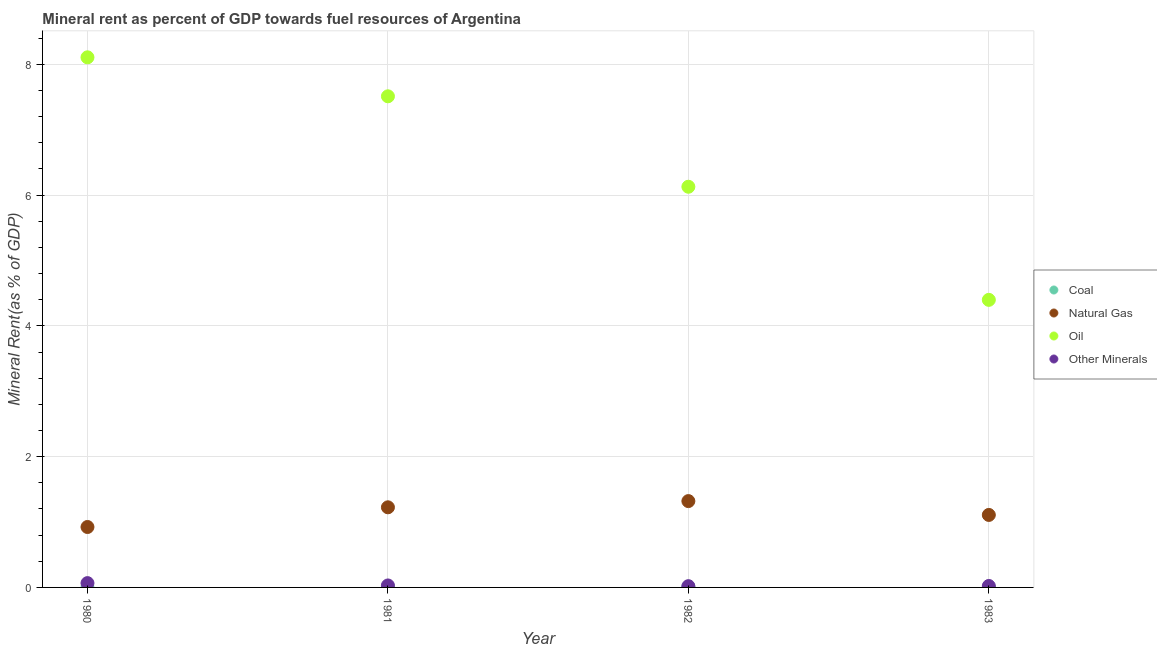How many different coloured dotlines are there?
Make the answer very short. 4. What is the coal rent in 1983?
Offer a very short reply. 0. Across all years, what is the maximum natural gas rent?
Provide a short and direct response. 1.32. Across all years, what is the minimum  rent of other minerals?
Provide a succinct answer. 0.02. What is the total oil rent in the graph?
Make the answer very short. 26.14. What is the difference between the coal rent in 1980 and that in 1983?
Your response must be concise. 0. What is the difference between the natural gas rent in 1982 and the coal rent in 1983?
Offer a terse response. 1.32. What is the average natural gas rent per year?
Provide a succinct answer. 1.14. In the year 1981, what is the difference between the oil rent and  rent of other minerals?
Offer a very short reply. 7.48. What is the ratio of the  rent of other minerals in 1980 to that in 1983?
Your response must be concise. 2.97. Is the difference between the coal rent in 1980 and 1981 greater than the difference between the natural gas rent in 1980 and 1981?
Keep it short and to the point. Yes. What is the difference between the highest and the second highest natural gas rent?
Offer a terse response. 0.1. What is the difference between the highest and the lowest natural gas rent?
Your answer should be very brief. 0.4. Is the sum of the natural gas rent in 1981 and 1982 greater than the maximum coal rent across all years?
Offer a terse response. Yes. Is the natural gas rent strictly less than the  rent of other minerals over the years?
Make the answer very short. No. How many dotlines are there?
Your answer should be very brief. 4. How many years are there in the graph?
Keep it short and to the point. 4. What is the difference between two consecutive major ticks on the Y-axis?
Make the answer very short. 2. Are the values on the major ticks of Y-axis written in scientific E-notation?
Give a very brief answer. No. Does the graph contain any zero values?
Your answer should be compact. No. Does the graph contain grids?
Offer a terse response. Yes. What is the title of the graph?
Make the answer very short. Mineral rent as percent of GDP towards fuel resources of Argentina. What is the label or title of the X-axis?
Offer a terse response. Year. What is the label or title of the Y-axis?
Ensure brevity in your answer.  Mineral Rent(as % of GDP). What is the Mineral Rent(as % of GDP) in Coal in 1980?
Your response must be concise. 0. What is the Mineral Rent(as % of GDP) in Natural Gas in 1980?
Provide a short and direct response. 0.92. What is the Mineral Rent(as % of GDP) in Oil in 1980?
Offer a terse response. 8.11. What is the Mineral Rent(as % of GDP) of Other Minerals in 1980?
Offer a terse response. 0.07. What is the Mineral Rent(as % of GDP) in Coal in 1981?
Offer a terse response. 0.01. What is the Mineral Rent(as % of GDP) in Natural Gas in 1981?
Offer a terse response. 1.23. What is the Mineral Rent(as % of GDP) in Oil in 1981?
Give a very brief answer. 7.51. What is the Mineral Rent(as % of GDP) in Other Minerals in 1981?
Keep it short and to the point. 0.03. What is the Mineral Rent(as % of GDP) in Coal in 1982?
Your answer should be compact. 0.01. What is the Mineral Rent(as % of GDP) of Natural Gas in 1982?
Ensure brevity in your answer.  1.32. What is the Mineral Rent(as % of GDP) in Oil in 1982?
Offer a terse response. 6.13. What is the Mineral Rent(as % of GDP) of Other Minerals in 1982?
Provide a short and direct response. 0.02. What is the Mineral Rent(as % of GDP) of Coal in 1983?
Offer a terse response. 0. What is the Mineral Rent(as % of GDP) in Natural Gas in 1983?
Make the answer very short. 1.11. What is the Mineral Rent(as % of GDP) in Oil in 1983?
Keep it short and to the point. 4.4. What is the Mineral Rent(as % of GDP) in Other Minerals in 1983?
Offer a terse response. 0.02. Across all years, what is the maximum Mineral Rent(as % of GDP) of Coal?
Your response must be concise. 0.01. Across all years, what is the maximum Mineral Rent(as % of GDP) of Natural Gas?
Provide a short and direct response. 1.32. Across all years, what is the maximum Mineral Rent(as % of GDP) in Oil?
Provide a succinct answer. 8.11. Across all years, what is the maximum Mineral Rent(as % of GDP) in Other Minerals?
Your answer should be very brief. 0.07. Across all years, what is the minimum Mineral Rent(as % of GDP) of Coal?
Your response must be concise. 0. Across all years, what is the minimum Mineral Rent(as % of GDP) in Natural Gas?
Give a very brief answer. 0.92. Across all years, what is the minimum Mineral Rent(as % of GDP) of Oil?
Your answer should be very brief. 4.4. Across all years, what is the minimum Mineral Rent(as % of GDP) of Other Minerals?
Offer a terse response. 0.02. What is the total Mineral Rent(as % of GDP) of Coal in the graph?
Offer a very short reply. 0.02. What is the total Mineral Rent(as % of GDP) of Natural Gas in the graph?
Provide a short and direct response. 4.58. What is the total Mineral Rent(as % of GDP) in Oil in the graph?
Provide a succinct answer. 26.14. What is the total Mineral Rent(as % of GDP) in Other Minerals in the graph?
Make the answer very short. 0.14. What is the difference between the Mineral Rent(as % of GDP) of Coal in 1980 and that in 1981?
Make the answer very short. -0.01. What is the difference between the Mineral Rent(as % of GDP) of Natural Gas in 1980 and that in 1981?
Give a very brief answer. -0.3. What is the difference between the Mineral Rent(as % of GDP) of Oil in 1980 and that in 1981?
Your answer should be compact. 0.6. What is the difference between the Mineral Rent(as % of GDP) in Other Minerals in 1980 and that in 1981?
Provide a short and direct response. 0.04. What is the difference between the Mineral Rent(as % of GDP) of Coal in 1980 and that in 1982?
Provide a succinct answer. -0.01. What is the difference between the Mineral Rent(as % of GDP) in Natural Gas in 1980 and that in 1982?
Ensure brevity in your answer.  -0.4. What is the difference between the Mineral Rent(as % of GDP) of Oil in 1980 and that in 1982?
Ensure brevity in your answer.  1.98. What is the difference between the Mineral Rent(as % of GDP) of Other Minerals in 1980 and that in 1982?
Keep it short and to the point. 0.05. What is the difference between the Mineral Rent(as % of GDP) in Natural Gas in 1980 and that in 1983?
Your answer should be very brief. -0.18. What is the difference between the Mineral Rent(as % of GDP) in Oil in 1980 and that in 1983?
Give a very brief answer. 3.71. What is the difference between the Mineral Rent(as % of GDP) in Other Minerals in 1980 and that in 1983?
Keep it short and to the point. 0.04. What is the difference between the Mineral Rent(as % of GDP) in Coal in 1981 and that in 1982?
Ensure brevity in your answer.  -0. What is the difference between the Mineral Rent(as % of GDP) of Natural Gas in 1981 and that in 1982?
Give a very brief answer. -0.1. What is the difference between the Mineral Rent(as % of GDP) of Oil in 1981 and that in 1982?
Your answer should be very brief. 1.38. What is the difference between the Mineral Rent(as % of GDP) of Other Minerals in 1981 and that in 1982?
Keep it short and to the point. 0.01. What is the difference between the Mineral Rent(as % of GDP) of Coal in 1981 and that in 1983?
Give a very brief answer. 0.01. What is the difference between the Mineral Rent(as % of GDP) in Natural Gas in 1981 and that in 1983?
Make the answer very short. 0.12. What is the difference between the Mineral Rent(as % of GDP) in Oil in 1981 and that in 1983?
Provide a succinct answer. 3.11. What is the difference between the Mineral Rent(as % of GDP) in Other Minerals in 1981 and that in 1983?
Offer a very short reply. 0.01. What is the difference between the Mineral Rent(as % of GDP) in Coal in 1982 and that in 1983?
Make the answer very short. 0.01. What is the difference between the Mineral Rent(as % of GDP) of Natural Gas in 1982 and that in 1983?
Give a very brief answer. 0.21. What is the difference between the Mineral Rent(as % of GDP) of Oil in 1982 and that in 1983?
Provide a short and direct response. 1.73. What is the difference between the Mineral Rent(as % of GDP) in Other Minerals in 1982 and that in 1983?
Give a very brief answer. -0. What is the difference between the Mineral Rent(as % of GDP) of Coal in 1980 and the Mineral Rent(as % of GDP) of Natural Gas in 1981?
Make the answer very short. -1.22. What is the difference between the Mineral Rent(as % of GDP) of Coal in 1980 and the Mineral Rent(as % of GDP) of Oil in 1981?
Provide a succinct answer. -7.51. What is the difference between the Mineral Rent(as % of GDP) of Coal in 1980 and the Mineral Rent(as % of GDP) of Other Minerals in 1981?
Provide a short and direct response. -0.03. What is the difference between the Mineral Rent(as % of GDP) of Natural Gas in 1980 and the Mineral Rent(as % of GDP) of Oil in 1981?
Keep it short and to the point. -6.59. What is the difference between the Mineral Rent(as % of GDP) in Natural Gas in 1980 and the Mineral Rent(as % of GDP) in Other Minerals in 1981?
Offer a terse response. 0.89. What is the difference between the Mineral Rent(as % of GDP) in Oil in 1980 and the Mineral Rent(as % of GDP) in Other Minerals in 1981?
Make the answer very short. 8.08. What is the difference between the Mineral Rent(as % of GDP) of Coal in 1980 and the Mineral Rent(as % of GDP) of Natural Gas in 1982?
Give a very brief answer. -1.32. What is the difference between the Mineral Rent(as % of GDP) in Coal in 1980 and the Mineral Rent(as % of GDP) in Oil in 1982?
Offer a terse response. -6.13. What is the difference between the Mineral Rent(as % of GDP) of Coal in 1980 and the Mineral Rent(as % of GDP) of Other Minerals in 1982?
Your response must be concise. -0.02. What is the difference between the Mineral Rent(as % of GDP) of Natural Gas in 1980 and the Mineral Rent(as % of GDP) of Oil in 1982?
Ensure brevity in your answer.  -5.2. What is the difference between the Mineral Rent(as % of GDP) of Natural Gas in 1980 and the Mineral Rent(as % of GDP) of Other Minerals in 1982?
Provide a short and direct response. 0.91. What is the difference between the Mineral Rent(as % of GDP) of Oil in 1980 and the Mineral Rent(as % of GDP) of Other Minerals in 1982?
Make the answer very short. 8.09. What is the difference between the Mineral Rent(as % of GDP) in Coal in 1980 and the Mineral Rent(as % of GDP) in Natural Gas in 1983?
Offer a terse response. -1.11. What is the difference between the Mineral Rent(as % of GDP) of Coal in 1980 and the Mineral Rent(as % of GDP) of Oil in 1983?
Provide a short and direct response. -4.4. What is the difference between the Mineral Rent(as % of GDP) in Coal in 1980 and the Mineral Rent(as % of GDP) in Other Minerals in 1983?
Provide a succinct answer. -0.02. What is the difference between the Mineral Rent(as % of GDP) of Natural Gas in 1980 and the Mineral Rent(as % of GDP) of Oil in 1983?
Offer a very short reply. -3.47. What is the difference between the Mineral Rent(as % of GDP) in Natural Gas in 1980 and the Mineral Rent(as % of GDP) in Other Minerals in 1983?
Your answer should be very brief. 0.9. What is the difference between the Mineral Rent(as % of GDP) in Oil in 1980 and the Mineral Rent(as % of GDP) in Other Minerals in 1983?
Provide a short and direct response. 8.08. What is the difference between the Mineral Rent(as % of GDP) in Coal in 1981 and the Mineral Rent(as % of GDP) in Natural Gas in 1982?
Provide a short and direct response. -1.31. What is the difference between the Mineral Rent(as % of GDP) of Coal in 1981 and the Mineral Rent(as % of GDP) of Oil in 1982?
Offer a very short reply. -6.12. What is the difference between the Mineral Rent(as % of GDP) of Coal in 1981 and the Mineral Rent(as % of GDP) of Other Minerals in 1982?
Keep it short and to the point. -0.01. What is the difference between the Mineral Rent(as % of GDP) in Natural Gas in 1981 and the Mineral Rent(as % of GDP) in Oil in 1982?
Provide a succinct answer. -4.9. What is the difference between the Mineral Rent(as % of GDP) of Natural Gas in 1981 and the Mineral Rent(as % of GDP) of Other Minerals in 1982?
Keep it short and to the point. 1.21. What is the difference between the Mineral Rent(as % of GDP) in Oil in 1981 and the Mineral Rent(as % of GDP) in Other Minerals in 1982?
Offer a terse response. 7.49. What is the difference between the Mineral Rent(as % of GDP) of Coal in 1981 and the Mineral Rent(as % of GDP) of Natural Gas in 1983?
Offer a terse response. -1.1. What is the difference between the Mineral Rent(as % of GDP) in Coal in 1981 and the Mineral Rent(as % of GDP) in Oil in 1983?
Offer a terse response. -4.39. What is the difference between the Mineral Rent(as % of GDP) in Coal in 1981 and the Mineral Rent(as % of GDP) in Other Minerals in 1983?
Offer a terse response. -0.01. What is the difference between the Mineral Rent(as % of GDP) in Natural Gas in 1981 and the Mineral Rent(as % of GDP) in Oil in 1983?
Make the answer very short. -3.17. What is the difference between the Mineral Rent(as % of GDP) of Natural Gas in 1981 and the Mineral Rent(as % of GDP) of Other Minerals in 1983?
Make the answer very short. 1.2. What is the difference between the Mineral Rent(as % of GDP) in Oil in 1981 and the Mineral Rent(as % of GDP) in Other Minerals in 1983?
Keep it short and to the point. 7.49. What is the difference between the Mineral Rent(as % of GDP) in Coal in 1982 and the Mineral Rent(as % of GDP) in Natural Gas in 1983?
Give a very brief answer. -1.1. What is the difference between the Mineral Rent(as % of GDP) in Coal in 1982 and the Mineral Rent(as % of GDP) in Oil in 1983?
Make the answer very short. -4.39. What is the difference between the Mineral Rent(as % of GDP) in Coal in 1982 and the Mineral Rent(as % of GDP) in Other Minerals in 1983?
Provide a succinct answer. -0.01. What is the difference between the Mineral Rent(as % of GDP) of Natural Gas in 1982 and the Mineral Rent(as % of GDP) of Oil in 1983?
Offer a terse response. -3.08. What is the difference between the Mineral Rent(as % of GDP) in Natural Gas in 1982 and the Mineral Rent(as % of GDP) in Other Minerals in 1983?
Give a very brief answer. 1.3. What is the difference between the Mineral Rent(as % of GDP) in Oil in 1982 and the Mineral Rent(as % of GDP) in Other Minerals in 1983?
Your answer should be very brief. 6.11. What is the average Mineral Rent(as % of GDP) in Coal per year?
Keep it short and to the point. 0.01. What is the average Mineral Rent(as % of GDP) in Natural Gas per year?
Make the answer very short. 1.14. What is the average Mineral Rent(as % of GDP) in Oil per year?
Give a very brief answer. 6.54. What is the average Mineral Rent(as % of GDP) of Other Minerals per year?
Offer a very short reply. 0.03. In the year 1980, what is the difference between the Mineral Rent(as % of GDP) of Coal and Mineral Rent(as % of GDP) of Natural Gas?
Ensure brevity in your answer.  -0.92. In the year 1980, what is the difference between the Mineral Rent(as % of GDP) in Coal and Mineral Rent(as % of GDP) in Oil?
Your answer should be very brief. -8.11. In the year 1980, what is the difference between the Mineral Rent(as % of GDP) of Coal and Mineral Rent(as % of GDP) of Other Minerals?
Your answer should be compact. -0.06. In the year 1980, what is the difference between the Mineral Rent(as % of GDP) in Natural Gas and Mineral Rent(as % of GDP) in Oil?
Your response must be concise. -7.18. In the year 1980, what is the difference between the Mineral Rent(as % of GDP) in Natural Gas and Mineral Rent(as % of GDP) in Other Minerals?
Offer a terse response. 0.86. In the year 1980, what is the difference between the Mineral Rent(as % of GDP) in Oil and Mineral Rent(as % of GDP) in Other Minerals?
Your answer should be compact. 8.04. In the year 1981, what is the difference between the Mineral Rent(as % of GDP) of Coal and Mineral Rent(as % of GDP) of Natural Gas?
Give a very brief answer. -1.22. In the year 1981, what is the difference between the Mineral Rent(as % of GDP) of Coal and Mineral Rent(as % of GDP) of Oil?
Your response must be concise. -7.5. In the year 1981, what is the difference between the Mineral Rent(as % of GDP) of Coal and Mineral Rent(as % of GDP) of Other Minerals?
Offer a terse response. -0.02. In the year 1981, what is the difference between the Mineral Rent(as % of GDP) of Natural Gas and Mineral Rent(as % of GDP) of Oil?
Offer a very short reply. -6.29. In the year 1981, what is the difference between the Mineral Rent(as % of GDP) in Natural Gas and Mineral Rent(as % of GDP) in Other Minerals?
Provide a short and direct response. 1.2. In the year 1981, what is the difference between the Mineral Rent(as % of GDP) of Oil and Mineral Rent(as % of GDP) of Other Minerals?
Make the answer very short. 7.48. In the year 1982, what is the difference between the Mineral Rent(as % of GDP) of Coal and Mineral Rent(as % of GDP) of Natural Gas?
Ensure brevity in your answer.  -1.31. In the year 1982, what is the difference between the Mineral Rent(as % of GDP) in Coal and Mineral Rent(as % of GDP) in Oil?
Offer a terse response. -6.12. In the year 1982, what is the difference between the Mineral Rent(as % of GDP) of Coal and Mineral Rent(as % of GDP) of Other Minerals?
Keep it short and to the point. -0.01. In the year 1982, what is the difference between the Mineral Rent(as % of GDP) in Natural Gas and Mineral Rent(as % of GDP) in Oil?
Offer a very short reply. -4.81. In the year 1982, what is the difference between the Mineral Rent(as % of GDP) of Natural Gas and Mineral Rent(as % of GDP) of Other Minerals?
Your answer should be very brief. 1.3. In the year 1982, what is the difference between the Mineral Rent(as % of GDP) in Oil and Mineral Rent(as % of GDP) in Other Minerals?
Keep it short and to the point. 6.11. In the year 1983, what is the difference between the Mineral Rent(as % of GDP) of Coal and Mineral Rent(as % of GDP) of Natural Gas?
Provide a short and direct response. -1.11. In the year 1983, what is the difference between the Mineral Rent(as % of GDP) of Coal and Mineral Rent(as % of GDP) of Oil?
Your response must be concise. -4.4. In the year 1983, what is the difference between the Mineral Rent(as % of GDP) of Coal and Mineral Rent(as % of GDP) of Other Minerals?
Your answer should be compact. -0.02. In the year 1983, what is the difference between the Mineral Rent(as % of GDP) of Natural Gas and Mineral Rent(as % of GDP) of Oil?
Your response must be concise. -3.29. In the year 1983, what is the difference between the Mineral Rent(as % of GDP) of Natural Gas and Mineral Rent(as % of GDP) of Other Minerals?
Provide a succinct answer. 1.09. In the year 1983, what is the difference between the Mineral Rent(as % of GDP) of Oil and Mineral Rent(as % of GDP) of Other Minerals?
Provide a short and direct response. 4.38. What is the ratio of the Mineral Rent(as % of GDP) in Coal in 1980 to that in 1981?
Provide a succinct answer. 0.18. What is the ratio of the Mineral Rent(as % of GDP) in Natural Gas in 1980 to that in 1981?
Ensure brevity in your answer.  0.75. What is the ratio of the Mineral Rent(as % of GDP) of Oil in 1980 to that in 1981?
Make the answer very short. 1.08. What is the ratio of the Mineral Rent(as % of GDP) of Other Minerals in 1980 to that in 1981?
Your response must be concise. 2.18. What is the ratio of the Mineral Rent(as % of GDP) of Coal in 1980 to that in 1982?
Your response must be concise. 0.17. What is the ratio of the Mineral Rent(as % of GDP) of Natural Gas in 1980 to that in 1982?
Provide a short and direct response. 0.7. What is the ratio of the Mineral Rent(as % of GDP) of Oil in 1980 to that in 1982?
Make the answer very short. 1.32. What is the ratio of the Mineral Rent(as % of GDP) in Other Minerals in 1980 to that in 1982?
Keep it short and to the point. 3.47. What is the ratio of the Mineral Rent(as % of GDP) in Coal in 1980 to that in 1983?
Ensure brevity in your answer.  1.08. What is the ratio of the Mineral Rent(as % of GDP) in Natural Gas in 1980 to that in 1983?
Your response must be concise. 0.83. What is the ratio of the Mineral Rent(as % of GDP) of Oil in 1980 to that in 1983?
Keep it short and to the point. 1.84. What is the ratio of the Mineral Rent(as % of GDP) in Other Minerals in 1980 to that in 1983?
Provide a succinct answer. 2.97. What is the ratio of the Mineral Rent(as % of GDP) in Coal in 1981 to that in 1982?
Offer a terse response. 0.92. What is the ratio of the Mineral Rent(as % of GDP) of Natural Gas in 1981 to that in 1982?
Make the answer very short. 0.93. What is the ratio of the Mineral Rent(as % of GDP) in Oil in 1981 to that in 1982?
Your response must be concise. 1.23. What is the ratio of the Mineral Rent(as % of GDP) in Other Minerals in 1981 to that in 1982?
Ensure brevity in your answer.  1.59. What is the ratio of the Mineral Rent(as % of GDP) of Coal in 1981 to that in 1983?
Your answer should be compact. 6. What is the ratio of the Mineral Rent(as % of GDP) of Natural Gas in 1981 to that in 1983?
Your response must be concise. 1.11. What is the ratio of the Mineral Rent(as % of GDP) of Oil in 1981 to that in 1983?
Offer a terse response. 1.71. What is the ratio of the Mineral Rent(as % of GDP) in Other Minerals in 1981 to that in 1983?
Offer a very short reply. 1.36. What is the ratio of the Mineral Rent(as % of GDP) in Coal in 1982 to that in 1983?
Give a very brief answer. 6.53. What is the ratio of the Mineral Rent(as % of GDP) in Natural Gas in 1982 to that in 1983?
Provide a short and direct response. 1.19. What is the ratio of the Mineral Rent(as % of GDP) in Oil in 1982 to that in 1983?
Offer a terse response. 1.39. What is the ratio of the Mineral Rent(as % of GDP) of Other Minerals in 1982 to that in 1983?
Provide a short and direct response. 0.86. What is the difference between the highest and the second highest Mineral Rent(as % of GDP) of Coal?
Offer a very short reply. 0. What is the difference between the highest and the second highest Mineral Rent(as % of GDP) of Natural Gas?
Provide a succinct answer. 0.1. What is the difference between the highest and the second highest Mineral Rent(as % of GDP) of Oil?
Give a very brief answer. 0.6. What is the difference between the highest and the second highest Mineral Rent(as % of GDP) in Other Minerals?
Make the answer very short. 0.04. What is the difference between the highest and the lowest Mineral Rent(as % of GDP) in Coal?
Offer a terse response. 0.01. What is the difference between the highest and the lowest Mineral Rent(as % of GDP) of Natural Gas?
Give a very brief answer. 0.4. What is the difference between the highest and the lowest Mineral Rent(as % of GDP) in Oil?
Provide a short and direct response. 3.71. What is the difference between the highest and the lowest Mineral Rent(as % of GDP) of Other Minerals?
Keep it short and to the point. 0.05. 